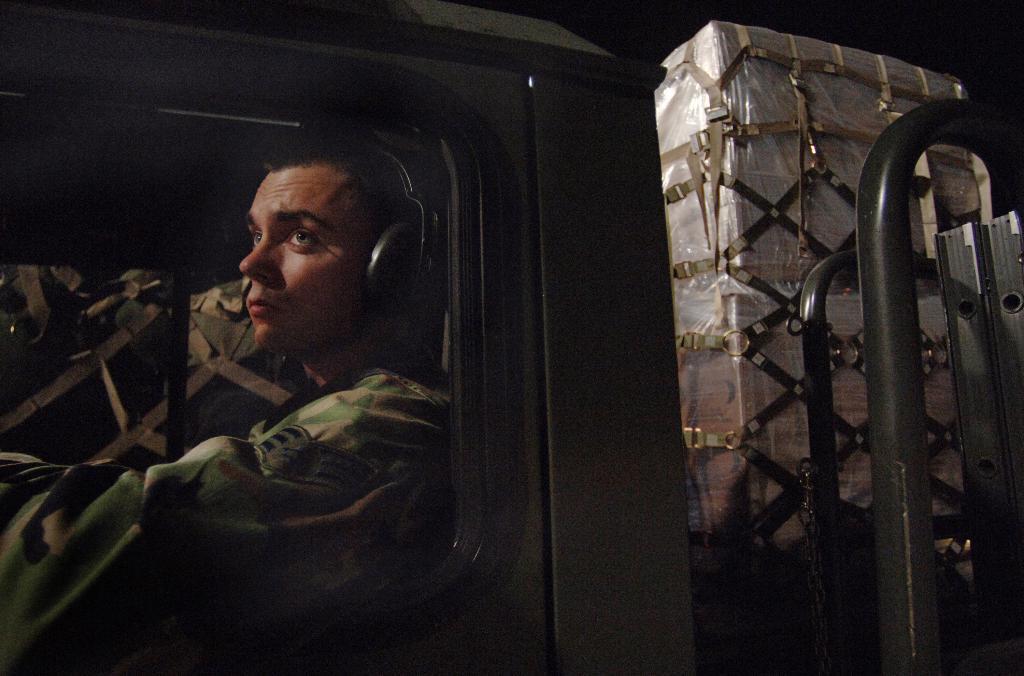In one or two sentences, can you explain what this image depicts? In this picture I can see a man on the left side, he is wearing an army dress. On the right side I can see goods packed with a plastic cover. 